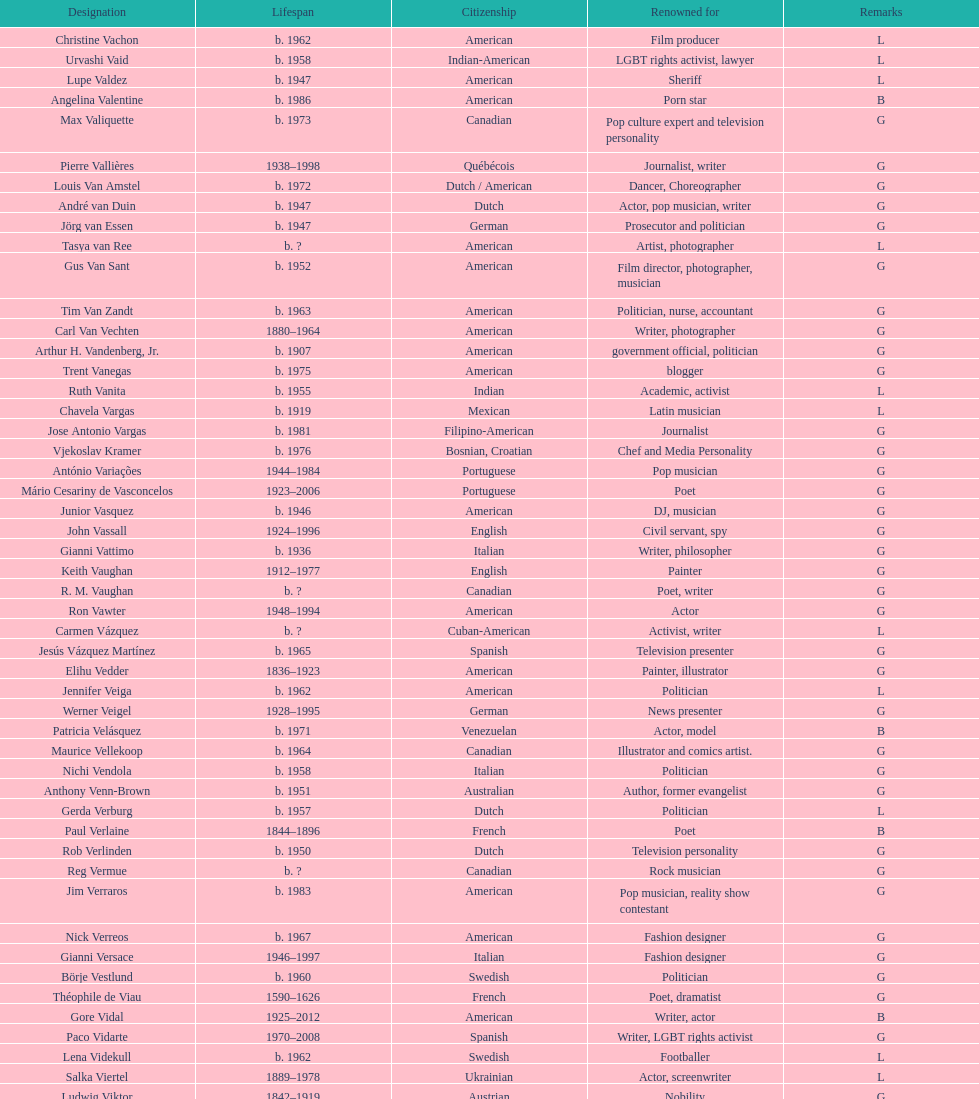Which nationality had the larger amount of names listed? American. 